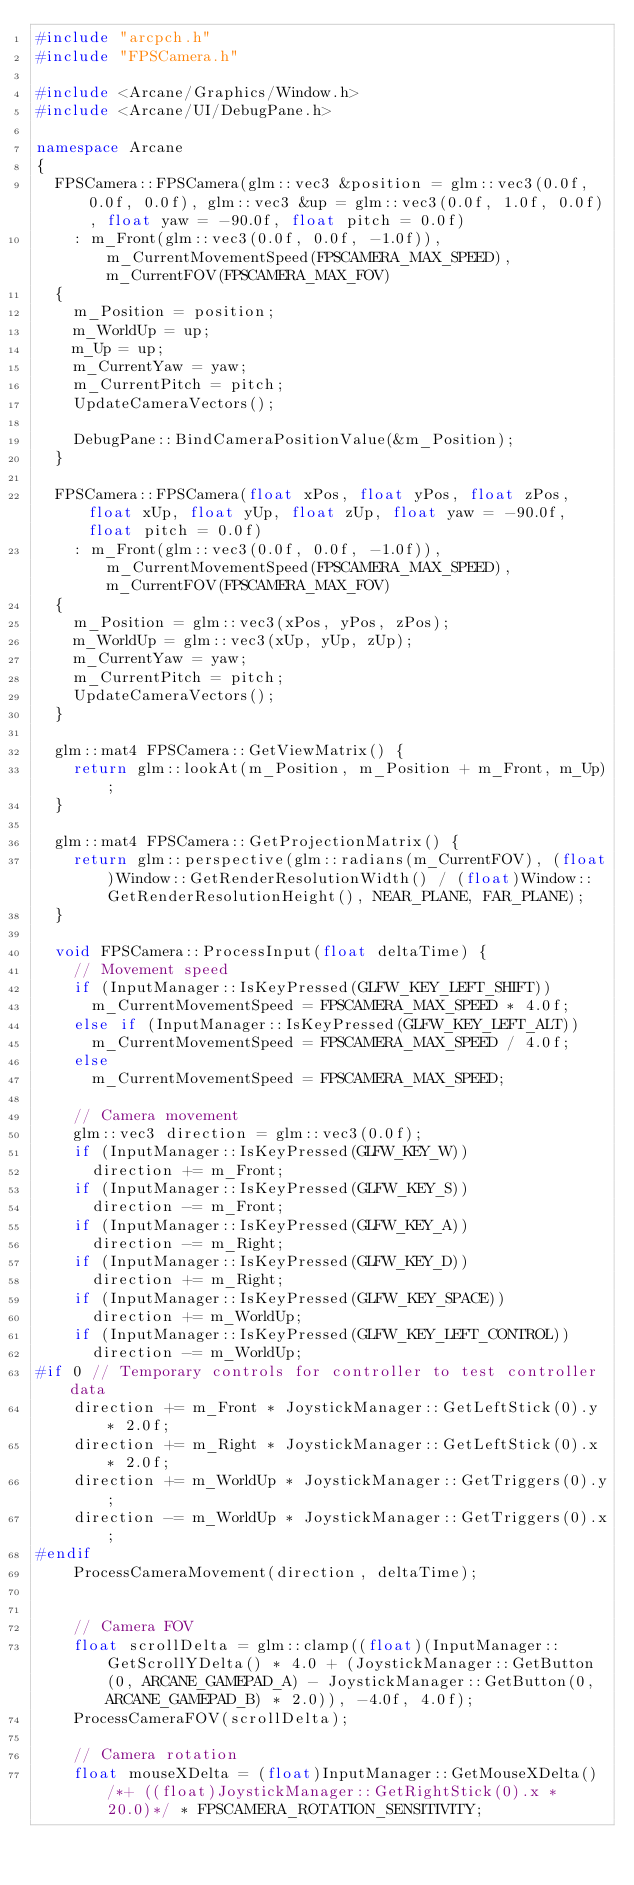<code> <loc_0><loc_0><loc_500><loc_500><_C++_>#include "arcpch.h"
#include "FPSCamera.h"

#include <Arcane/Graphics/Window.h>
#include <Arcane/UI/DebugPane.h>

namespace Arcane
{
	FPSCamera::FPSCamera(glm::vec3 &position = glm::vec3(0.0f, 0.0f, 0.0f), glm::vec3 &up = glm::vec3(0.0f, 1.0f, 0.0f), float yaw = -90.0f, float pitch = 0.0f)
		: m_Front(glm::vec3(0.0f, 0.0f, -1.0f)), m_CurrentMovementSpeed(FPSCAMERA_MAX_SPEED), m_CurrentFOV(FPSCAMERA_MAX_FOV)
	{
		m_Position = position;
		m_WorldUp = up;
		m_Up = up;
		m_CurrentYaw = yaw;
		m_CurrentPitch = pitch;
		UpdateCameraVectors();

		DebugPane::BindCameraPositionValue(&m_Position);
	}

	FPSCamera::FPSCamera(float xPos, float yPos, float zPos, float xUp, float yUp, float zUp, float yaw = -90.0f, float pitch = 0.0f)
		: m_Front(glm::vec3(0.0f, 0.0f, -1.0f)), m_CurrentMovementSpeed(FPSCAMERA_MAX_SPEED), m_CurrentFOV(FPSCAMERA_MAX_FOV)
	{
		m_Position = glm::vec3(xPos, yPos, zPos);
		m_WorldUp = glm::vec3(xUp, yUp, zUp);
		m_CurrentYaw = yaw;
		m_CurrentPitch = pitch;
		UpdateCameraVectors();
	}

	glm::mat4 FPSCamera::GetViewMatrix() {
		return glm::lookAt(m_Position, m_Position + m_Front, m_Up);
	}

	glm::mat4 FPSCamera::GetProjectionMatrix() {
		return glm::perspective(glm::radians(m_CurrentFOV), (float)Window::GetRenderResolutionWidth() / (float)Window::GetRenderResolutionHeight(), NEAR_PLANE, FAR_PLANE);
	}

	void FPSCamera::ProcessInput(float deltaTime) {
		// Movement speed
		if (InputManager::IsKeyPressed(GLFW_KEY_LEFT_SHIFT))
			m_CurrentMovementSpeed = FPSCAMERA_MAX_SPEED * 4.0f;
		else if (InputManager::IsKeyPressed(GLFW_KEY_LEFT_ALT))
			m_CurrentMovementSpeed = FPSCAMERA_MAX_SPEED / 4.0f;
		else
			m_CurrentMovementSpeed = FPSCAMERA_MAX_SPEED;

		// Camera movement
		glm::vec3 direction = glm::vec3(0.0f);
		if (InputManager::IsKeyPressed(GLFW_KEY_W))
			direction += m_Front;
		if (InputManager::IsKeyPressed(GLFW_KEY_S))
			direction -= m_Front;
		if (InputManager::IsKeyPressed(GLFW_KEY_A))
			direction -= m_Right;
		if (InputManager::IsKeyPressed(GLFW_KEY_D))
			direction += m_Right;
		if (InputManager::IsKeyPressed(GLFW_KEY_SPACE))
			direction += m_WorldUp;
		if (InputManager::IsKeyPressed(GLFW_KEY_LEFT_CONTROL))
			direction -= m_WorldUp;
#if 0 // Temporary controls for controller to test controller data
		direction += m_Front * JoystickManager::GetLeftStick(0).y * 2.0f;
		direction += m_Right * JoystickManager::GetLeftStick(0).x * 2.0f;
		direction += m_WorldUp * JoystickManager::GetTriggers(0).y;
		direction -= m_WorldUp * JoystickManager::GetTriggers(0).x;
#endif
		ProcessCameraMovement(direction, deltaTime);


		// Camera FOV
		float scrollDelta = glm::clamp((float)(InputManager::GetScrollYDelta() * 4.0 + (JoystickManager::GetButton(0, ARCANE_GAMEPAD_A) - JoystickManager::GetButton(0, ARCANE_GAMEPAD_B) * 2.0)), -4.0f, 4.0f);
		ProcessCameraFOV(scrollDelta);

		// Camera rotation
		float mouseXDelta = (float)InputManager::GetMouseXDelta() /*+ ((float)JoystickManager::GetRightStick(0).x * 20.0)*/ * FPSCAMERA_ROTATION_SENSITIVITY;</code> 